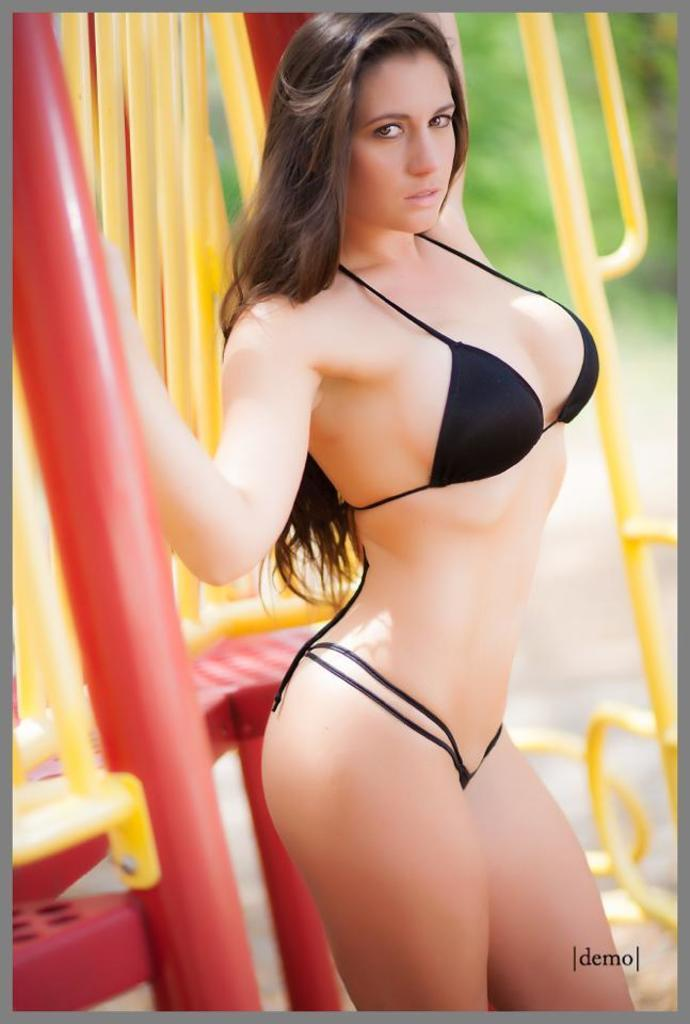What is the main subject of the image? There is a woman standing in the image. What is the woman holding in the image? The woman is holding a pole. What else can be seen in the background of the image? There are poles visible in the background of the image. What information is provided at the bottom of the image? There is text at the bottom of the image. How many girls are attempting to make a statement in the image? There is no girl present in the image, and no one is attempting to make a statement. 